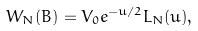<formula> <loc_0><loc_0><loc_500><loc_500>W _ { N } ( B ) = V _ { 0 } e ^ { - u / 2 } L _ { N } ( u ) ,</formula> 